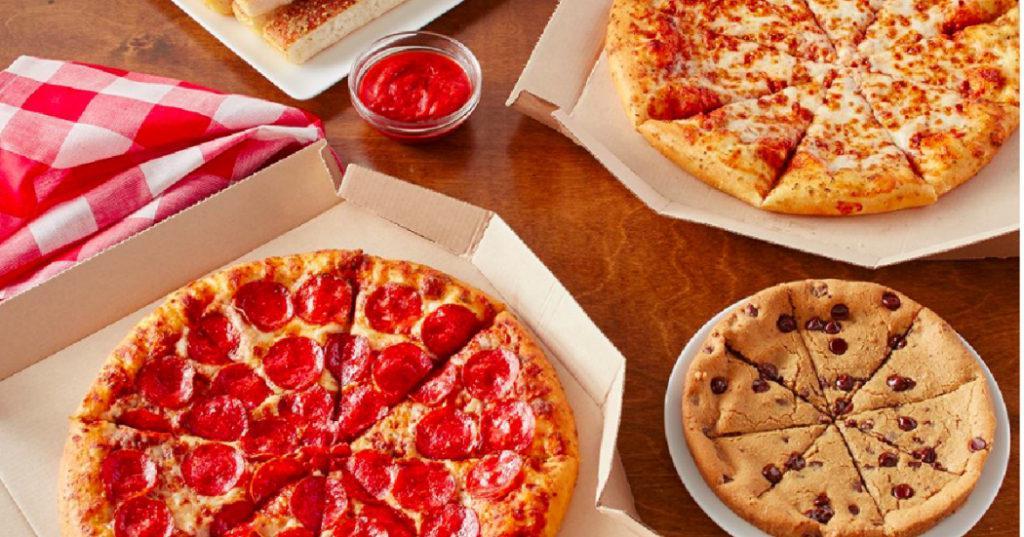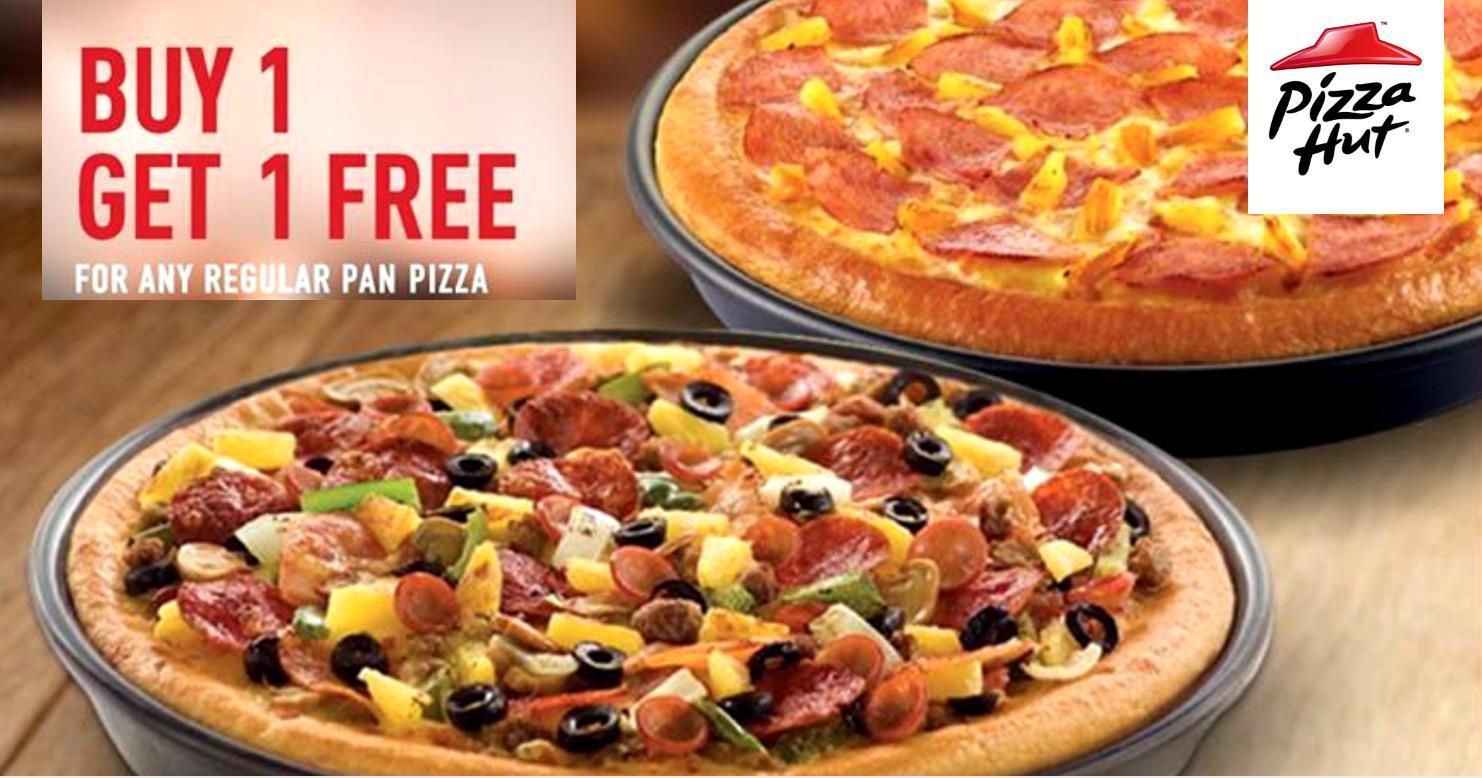The first image is the image on the left, the second image is the image on the right. Evaluate the accuracy of this statement regarding the images: "There are more pizzas in the image on the left.". Is it true? Answer yes or no. Yes. 